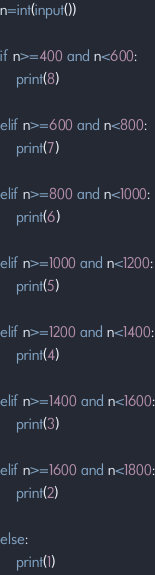<code> <loc_0><loc_0><loc_500><loc_500><_Python_>n=int(input())

if n>=400 and n<600:
    print(8)

elif n>=600 and n<800:
    print(7)

elif n>=800 and n<1000:
    print(6)

elif n>=1000 and n<1200:
    print(5)

elif n>=1200 and n<1400:
    print(4)

elif n>=1400 and n<1600:
    print(3)

elif n>=1600 and n<1800:
    print(2)

else:
    print(1)</code> 